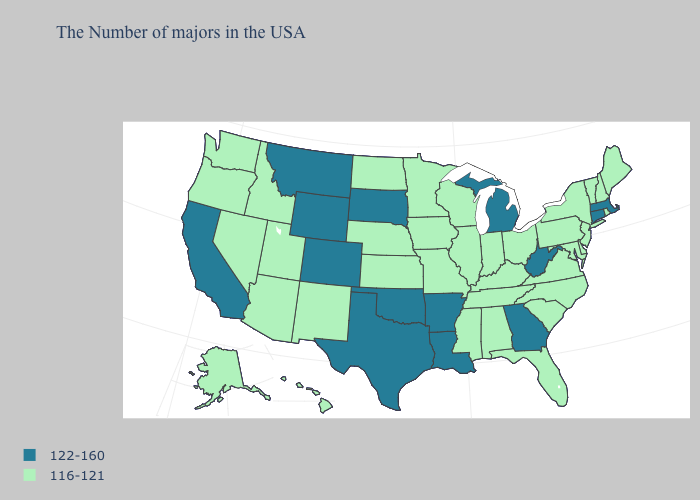Does the map have missing data?
Keep it brief. No. Name the states that have a value in the range 116-121?
Answer briefly. Maine, Rhode Island, New Hampshire, Vermont, New York, New Jersey, Delaware, Maryland, Pennsylvania, Virginia, North Carolina, South Carolina, Ohio, Florida, Kentucky, Indiana, Alabama, Tennessee, Wisconsin, Illinois, Mississippi, Missouri, Minnesota, Iowa, Kansas, Nebraska, North Dakota, New Mexico, Utah, Arizona, Idaho, Nevada, Washington, Oregon, Alaska, Hawaii. Does Texas have the lowest value in the USA?
Keep it brief. No. Name the states that have a value in the range 116-121?
Answer briefly. Maine, Rhode Island, New Hampshire, Vermont, New York, New Jersey, Delaware, Maryland, Pennsylvania, Virginia, North Carolina, South Carolina, Ohio, Florida, Kentucky, Indiana, Alabama, Tennessee, Wisconsin, Illinois, Mississippi, Missouri, Minnesota, Iowa, Kansas, Nebraska, North Dakota, New Mexico, Utah, Arizona, Idaho, Nevada, Washington, Oregon, Alaska, Hawaii. What is the value of Idaho?
Give a very brief answer. 116-121. What is the highest value in states that border Kansas?
Give a very brief answer. 122-160. Name the states that have a value in the range 122-160?
Give a very brief answer. Massachusetts, Connecticut, West Virginia, Georgia, Michigan, Louisiana, Arkansas, Oklahoma, Texas, South Dakota, Wyoming, Colorado, Montana, California. How many symbols are there in the legend?
Quick response, please. 2. What is the value of Montana?
Quick response, please. 122-160. Name the states that have a value in the range 116-121?
Keep it brief. Maine, Rhode Island, New Hampshire, Vermont, New York, New Jersey, Delaware, Maryland, Pennsylvania, Virginia, North Carolina, South Carolina, Ohio, Florida, Kentucky, Indiana, Alabama, Tennessee, Wisconsin, Illinois, Mississippi, Missouri, Minnesota, Iowa, Kansas, Nebraska, North Dakota, New Mexico, Utah, Arizona, Idaho, Nevada, Washington, Oregon, Alaska, Hawaii. Name the states that have a value in the range 122-160?
Concise answer only. Massachusetts, Connecticut, West Virginia, Georgia, Michigan, Louisiana, Arkansas, Oklahoma, Texas, South Dakota, Wyoming, Colorado, Montana, California. What is the lowest value in states that border Minnesota?
Concise answer only. 116-121. Which states have the highest value in the USA?
Keep it brief. Massachusetts, Connecticut, West Virginia, Georgia, Michigan, Louisiana, Arkansas, Oklahoma, Texas, South Dakota, Wyoming, Colorado, Montana, California. 